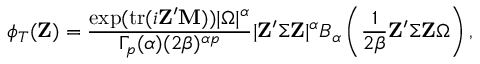Convert formula to latex. <formula><loc_0><loc_0><loc_500><loc_500>\phi _ { T } ( Z ) = { \frac { \exp ( { t r } ( i Z ^ { \prime } M ) ) | { \Omega } | ^ { \alpha } } { \Gamma _ { p } ( \alpha ) ( 2 \beta ) ^ { \alpha p } } } | Z ^ { \prime } { \Sigma } Z | ^ { \alpha } B _ { \alpha } \left ( { \frac { 1 } { 2 \beta } } Z ^ { \prime } { \Sigma } Z { \Omega } \right ) ,</formula> 